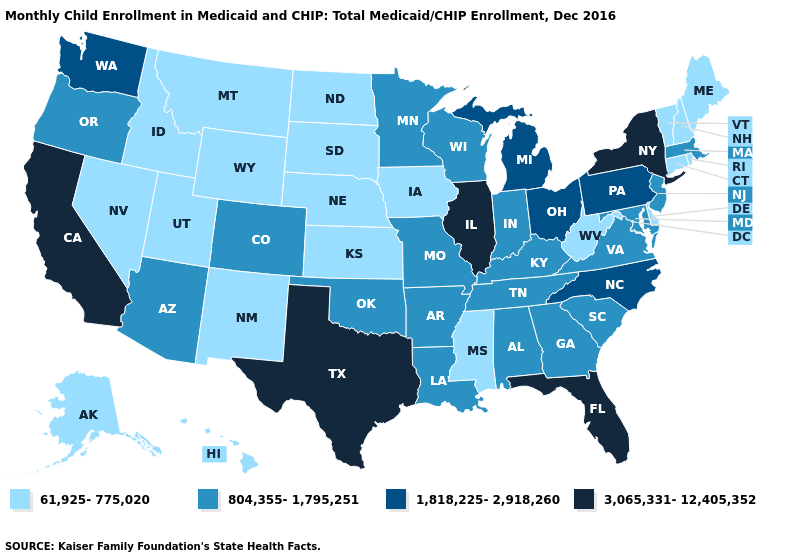Does the first symbol in the legend represent the smallest category?
Be succinct. Yes. What is the value of Utah?
Keep it brief. 61,925-775,020. Is the legend a continuous bar?
Quick response, please. No. Does Illinois have the highest value in the MidWest?
Quick response, please. Yes. Which states have the lowest value in the USA?
Concise answer only. Alaska, Connecticut, Delaware, Hawaii, Idaho, Iowa, Kansas, Maine, Mississippi, Montana, Nebraska, Nevada, New Hampshire, New Mexico, North Dakota, Rhode Island, South Dakota, Utah, Vermont, West Virginia, Wyoming. Name the states that have a value in the range 1,818,225-2,918,260?
Write a very short answer. Michigan, North Carolina, Ohio, Pennsylvania, Washington. What is the value of Oklahoma?
Write a very short answer. 804,355-1,795,251. What is the value of Maine?
Write a very short answer. 61,925-775,020. Does Tennessee have the same value as Pennsylvania?
Be succinct. No. What is the highest value in the South ?
Be succinct. 3,065,331-12,405,352. What is the highest value in states that border Louisiana?
Keep it brief. 3,065,331-12,405,352. Does Illinois have the highest value in the MidWest?
Quick response, please. Yes. What is the value of New Hampshire?
Give a very brief answer. 61,925-775,020. Name the states that have a value in the range 61,925-775,020?
Short answer required. Alaska, Connecticut, Delaware, Hawaii, Idaho, Iowa, Kansas, Maine, Mississippi, Montana, Nebraska, Nevada, New Hampshire, New Mexico, North Dakota, Rhode Island, South Dakota, Utah, Vermont, West Virginia, Wyoming. Does California have the lowest value in the West?
Be succinct. No. 